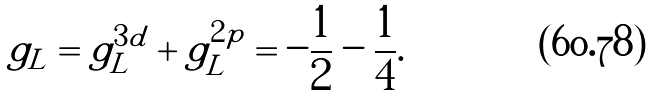Convert formula to latex. <formula><loc_0><loc_0><loc_500><loc_500>g _ { L } = g _ { L } ^ { 3 d } + g _ { L } ^ { 2 p } = - \frac { 1 } { 2 } - \frac { 1 } { 4 } .</formula> 